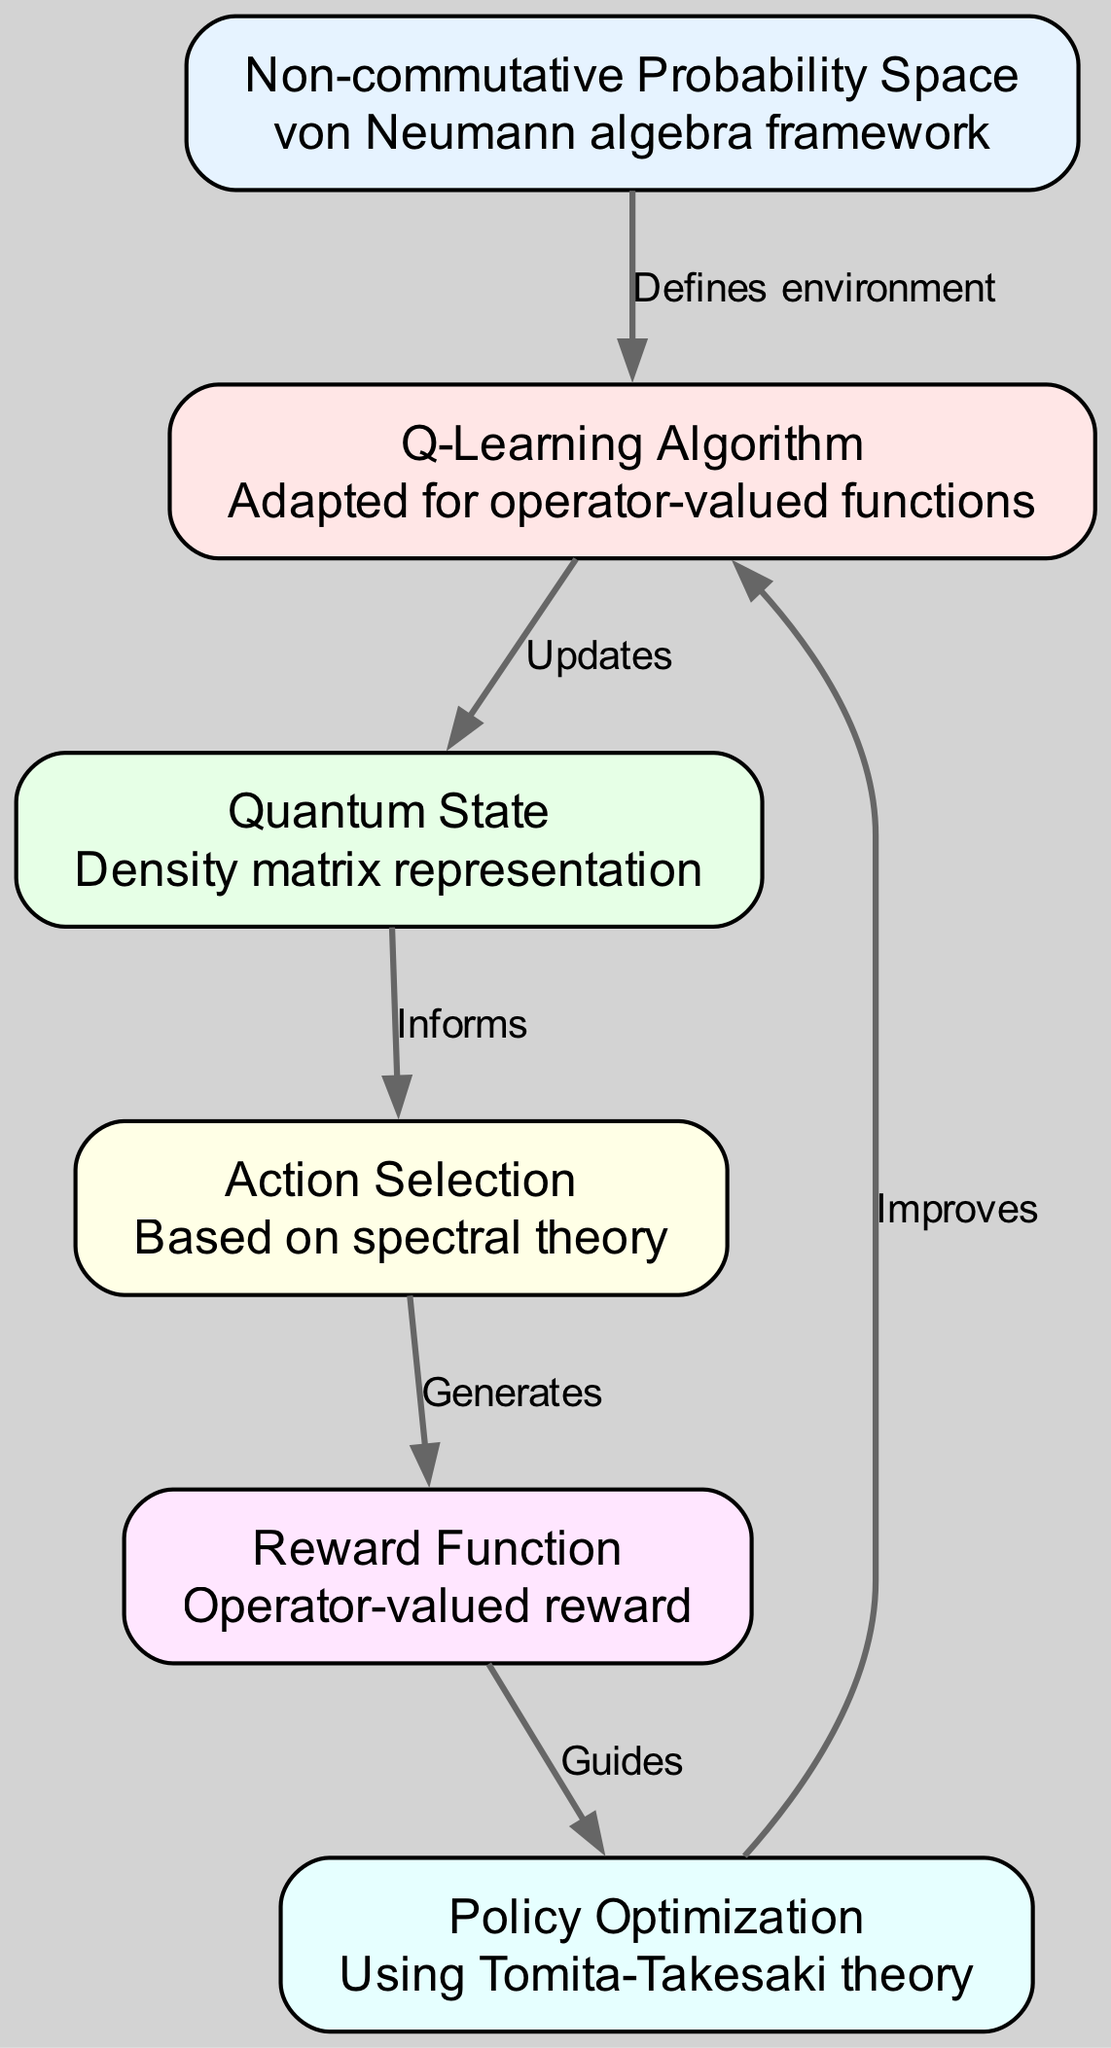What is the starting node in the diagram? The diagram starts with the "Non-commutative Probability Space" node, which defines the environment for the Q-Learning algorithm.
Answer: Non-commutative Probability Space How many nodes are present in the diagram? The diagram contains six nodes, each representing different components of the reinforcement learning algorithm in non-commutative probability theory.
Answer: Six What relationship exists between the "Q-Learning Algorithm" and "Quantum State"? The "Q-Learning Algorithm" updates the "Quantum State," indicating that the algorithm modifies or influences the representation of the quantum state during learning.
Answer: Updates Which node is informed by the "Quantum State"? The "Action Selection" node is informed by the "Quantum State," suggesting that the details from the quantum state shape the actions to be selected in the learning process.
Answer: Action Selection What guides the "Policy Optimization"? The "Reward Function" guides the "Policy Optimization," signifying that the feedback received through the reward function directs the optimization of the policy strategy.
Answer: Reward Function How does the "Policy Optimization" improve the "Q-Learning Algorithm"? "Policy Optimization" improves the "Q-Learning Algorithm" by iteratively refining the strategy based on the learned policies from previous iterations through Tomita-Takesaki theory.
Answer: Improves Which node generates the "Reward Function"? The "Action Selection" node generates the "Reward Function," indicating that the actions chosen lead to the creation of the resulting rewards considered in the learning process.
Answer: Generates What theory is used for "Policy Optimization"? The Tomita-Takesaki theory is employed for "Policy Optimization," emphasizing its foundational role in informing the optimization procedures in the context of non-commutative probability theory.
Answer: Tomita-Takesaki theory Which component defines the learning environment for the algorithm? The "Non-commutative Probability Space" defines the learning environment, as it provides the conceptual framework in which the remaining components operate.
Answer: Defines environment 